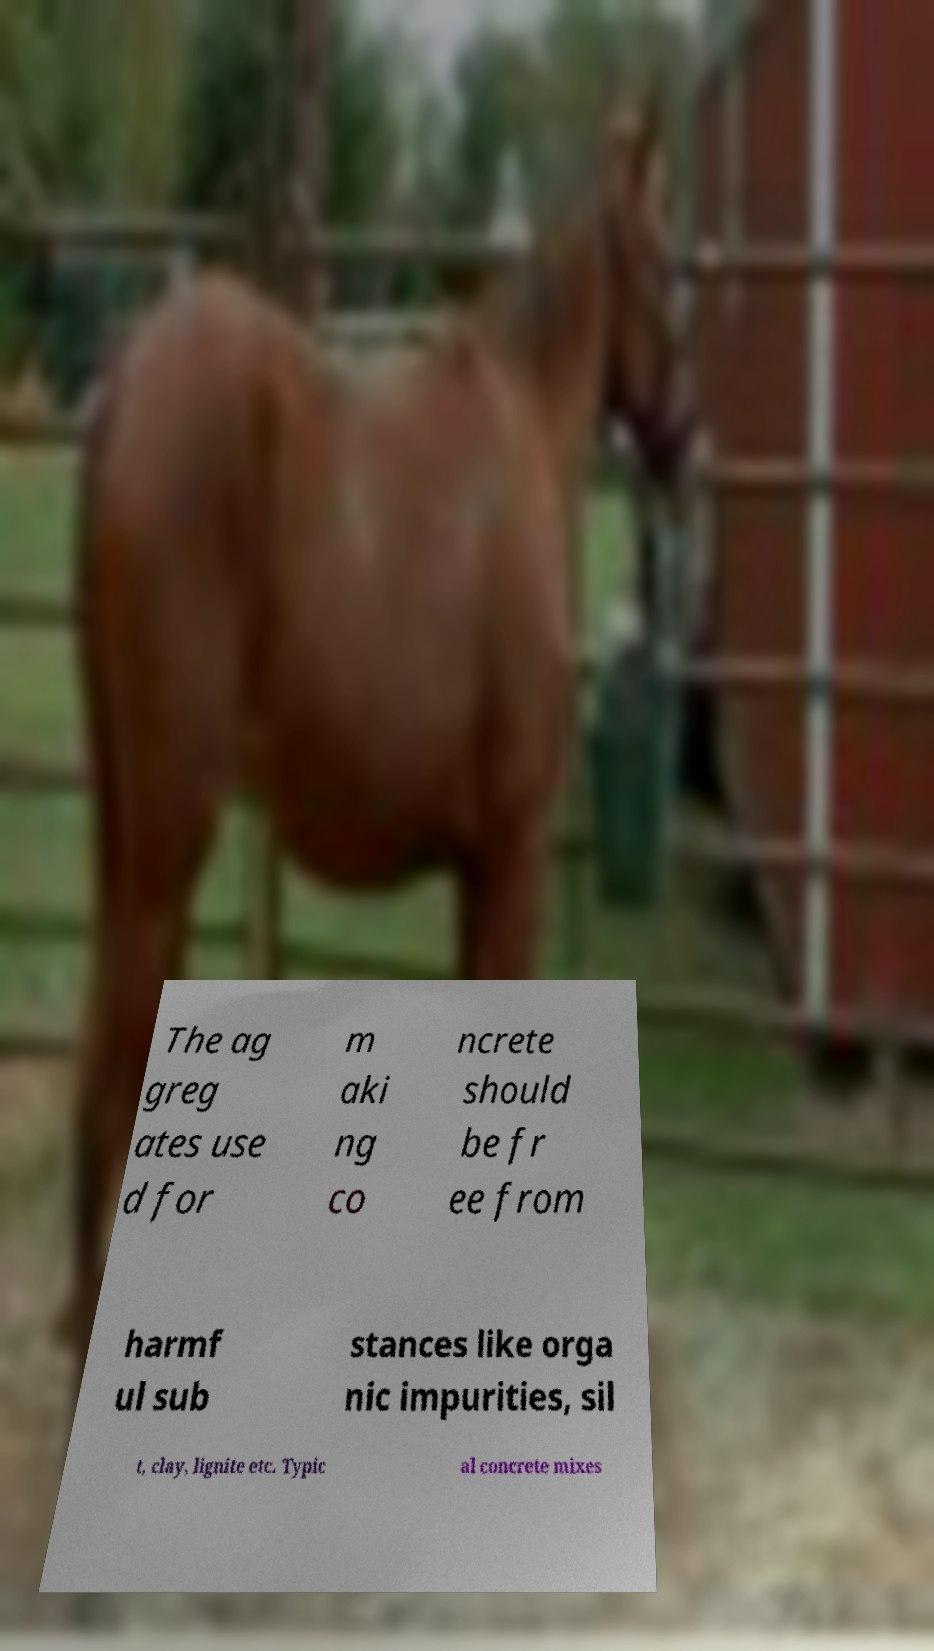Could you extract and type out the text from this image? The ag greg ates use d for m aki ng co ncrete should be fr ee from harmf ul sub stances like orga nic impurities, sil t, clay, lignite etc. Typic al concrete mixes 